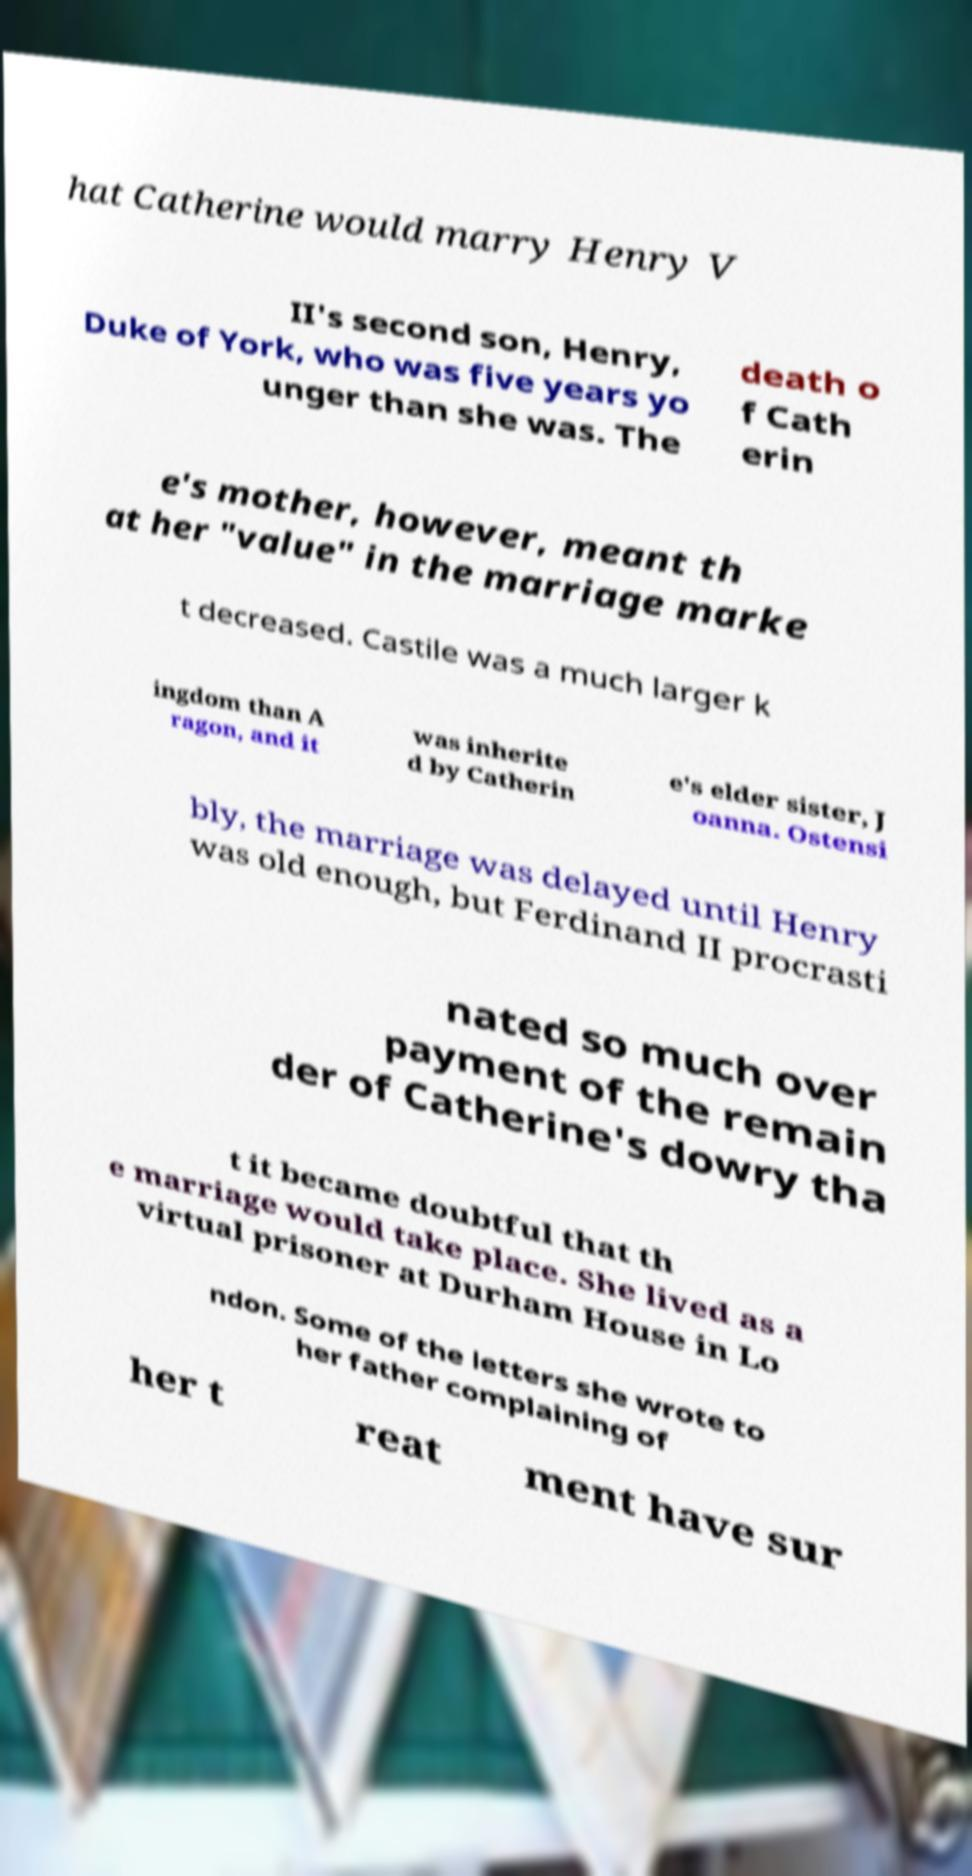Could you extract and type out the text from this image? hat Catherine would marry Henry V II's second son, Henry, Duke of York, who was five years yo unger than she was. The death o f Cath erin e's mother, however, meant th at her "value" in the marriage marke t decreased. Castile was a much larger k ingdom than A ragon, and it was inherite d by Catherin e's elder sister, J oanna. Ostensi bly, the marriage was delayed until Henry was old enough, but Ferdinand II procrasti nated so much over payment of the remain der of Catherine's dowry tha t it became doubtful that th e marriage would take place. She lived as a virtual prisoner at Durham House in Lo ndon. Some of the letters she wrote to her father complaining of her t reat ment have sur 